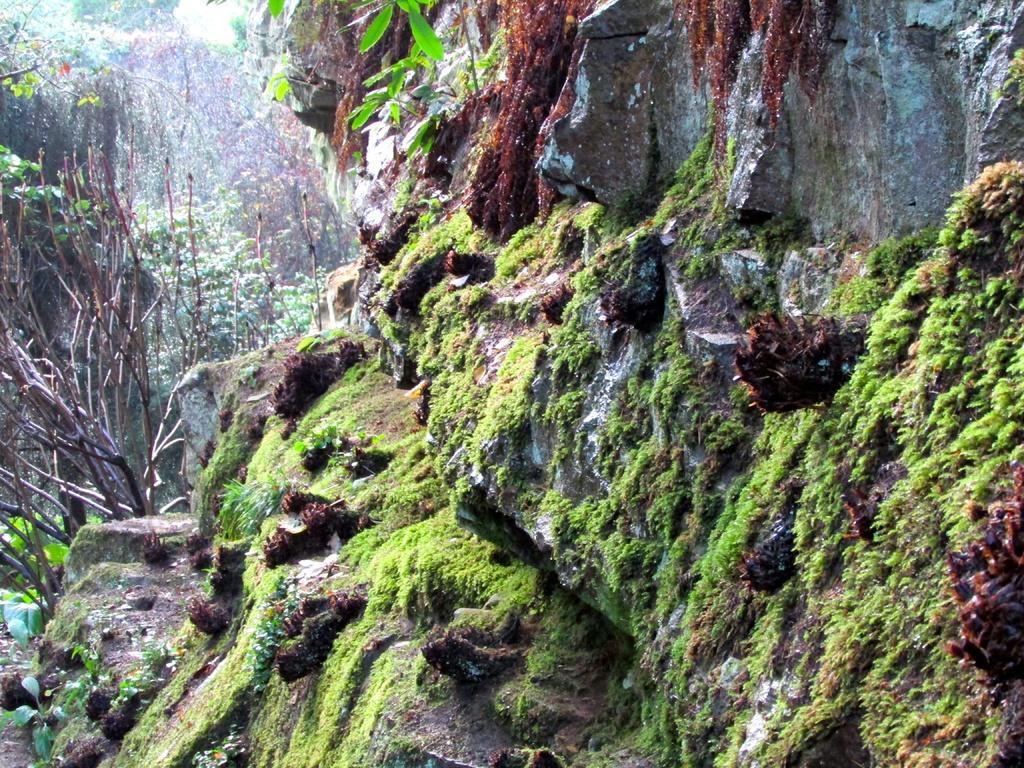Can you describe this image briefly? In this image there are some rocks, and on the rocks there is some grass and in the background there are some trees and plants. 